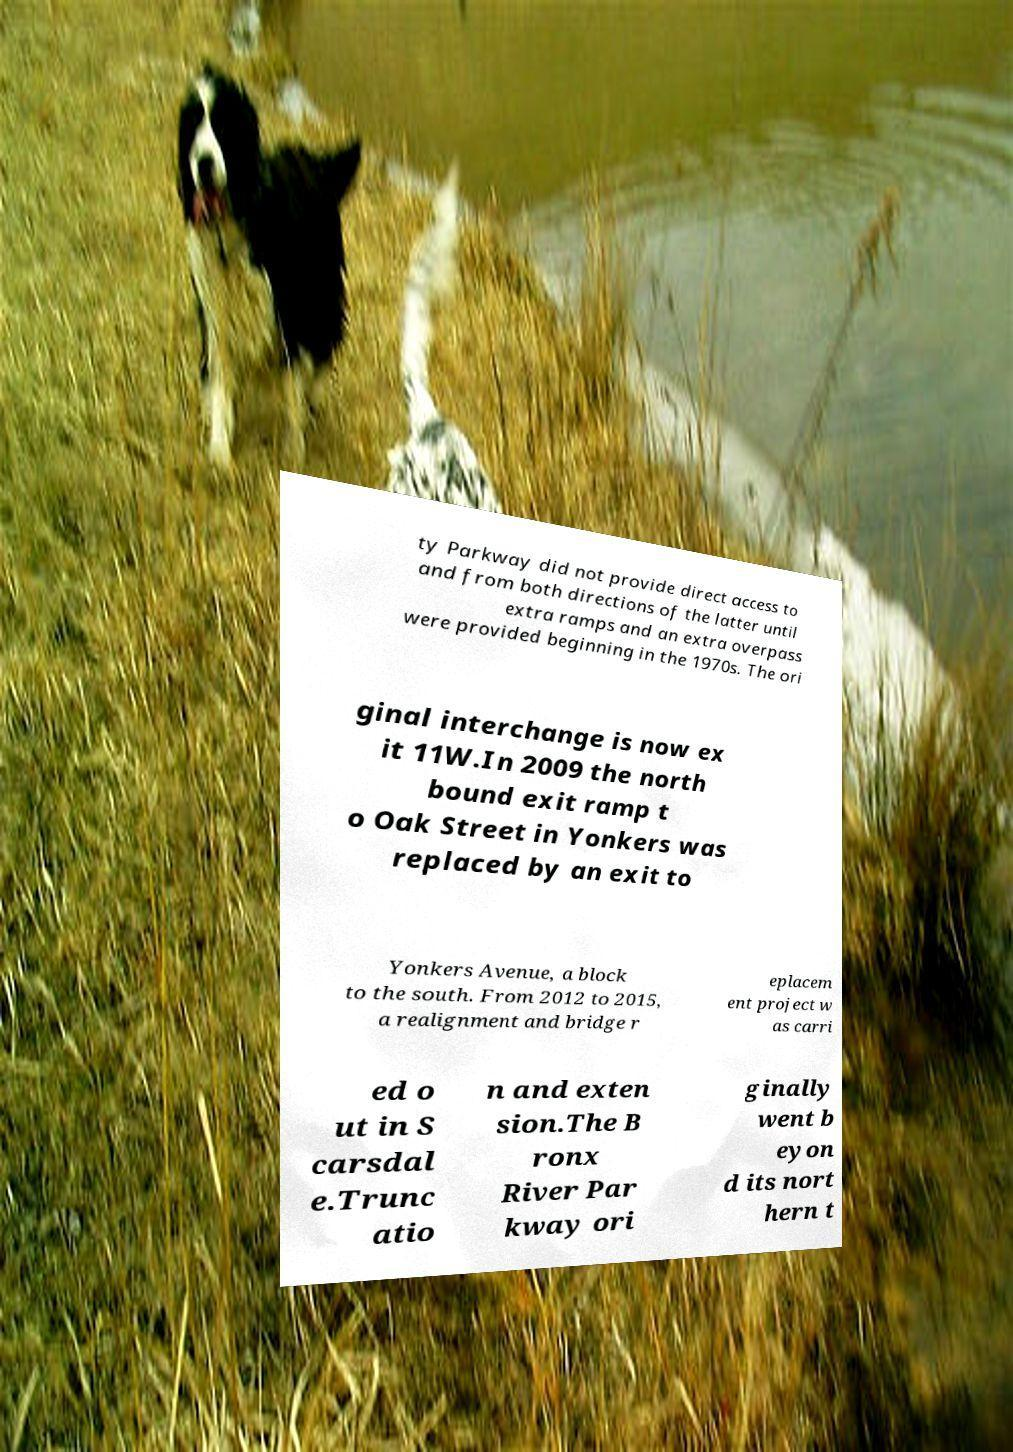Could you extract and type out the text from this image? ty Parkway did not provide direct access to and from both directions of the latter until extra ramps and an extra overpass were provided beginning in the 1970s. The ori ginal interchange is now ex it 11W.In 2009 the north bound exit ramp t o Oak Street in Yonkers was replaced by an exit to Yonkers Avenue, a block to the south. From 2012 to 2015, a realignment and bridge r eplacem ent project w as carri ed o ut in S carsdal e.Trunc atio n and exten sion.The B ronx River Par kway ori ginally went b eyon d its nort hern t 